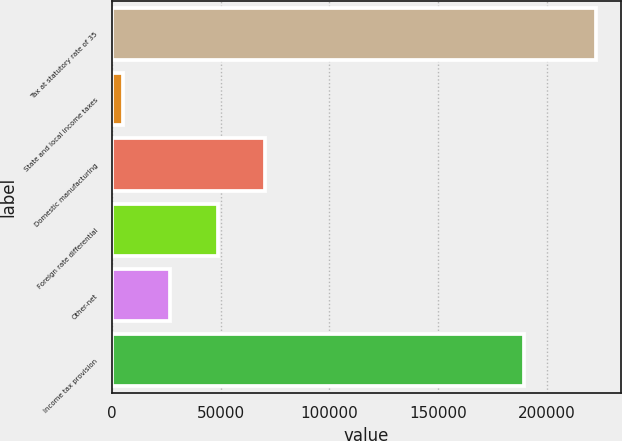Convert chart. <chart><loc_0><loc_0><loc_500><loc_500><bar_chart><fcel>Tax at statutory rate of 35<fcel>State and local income taxes<fcel>Domestic manufacturing<fcel>Foreign rate differential<fcel>Other-net<fcel>Income tax provision<nl><fcel>222888<fcel>4931<fcel>70318.1<fcel>48522.4<fcel>26726.7<fcel>189612<nl></chart> 